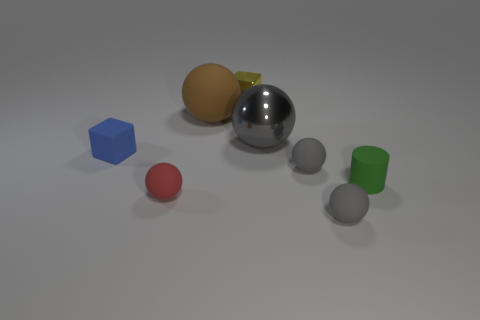Subtract all brown blocks. How many gray balls are left? 3 Subtract all gray metal spheres. How many spheres are left? 4 Subtract all brown balls. How many balls are left? 4 Subtract all green spheres. Subtract all purple cylinders. How many spheres are left? 5 Add 1 tiny gray matte objects. How many objects exist? 9 Subtract all cylinders. How many objects are left? 7 Subtract 1 green cylinders. How many objects are left? 7 Subtract all cylinders. Subtract all matte cylinders. How many objects are left? 6 Add 1 small gray matte spheres. How many small gray matte spheres are left? 3 Add 8 big metal things. How many big metal things exist? 9 